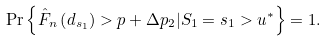<formula> <loc_0><loc_0><loc_500><loc_500>\Pr \left \{ \hat { F } _ { n } \left ( d _ { s _ { 1 } } \right ) > p + \Delta p _ { 2 } | S _ { 1 } = s _ { 1 } > u ^ { * } \right \} = 1 .</formula> 